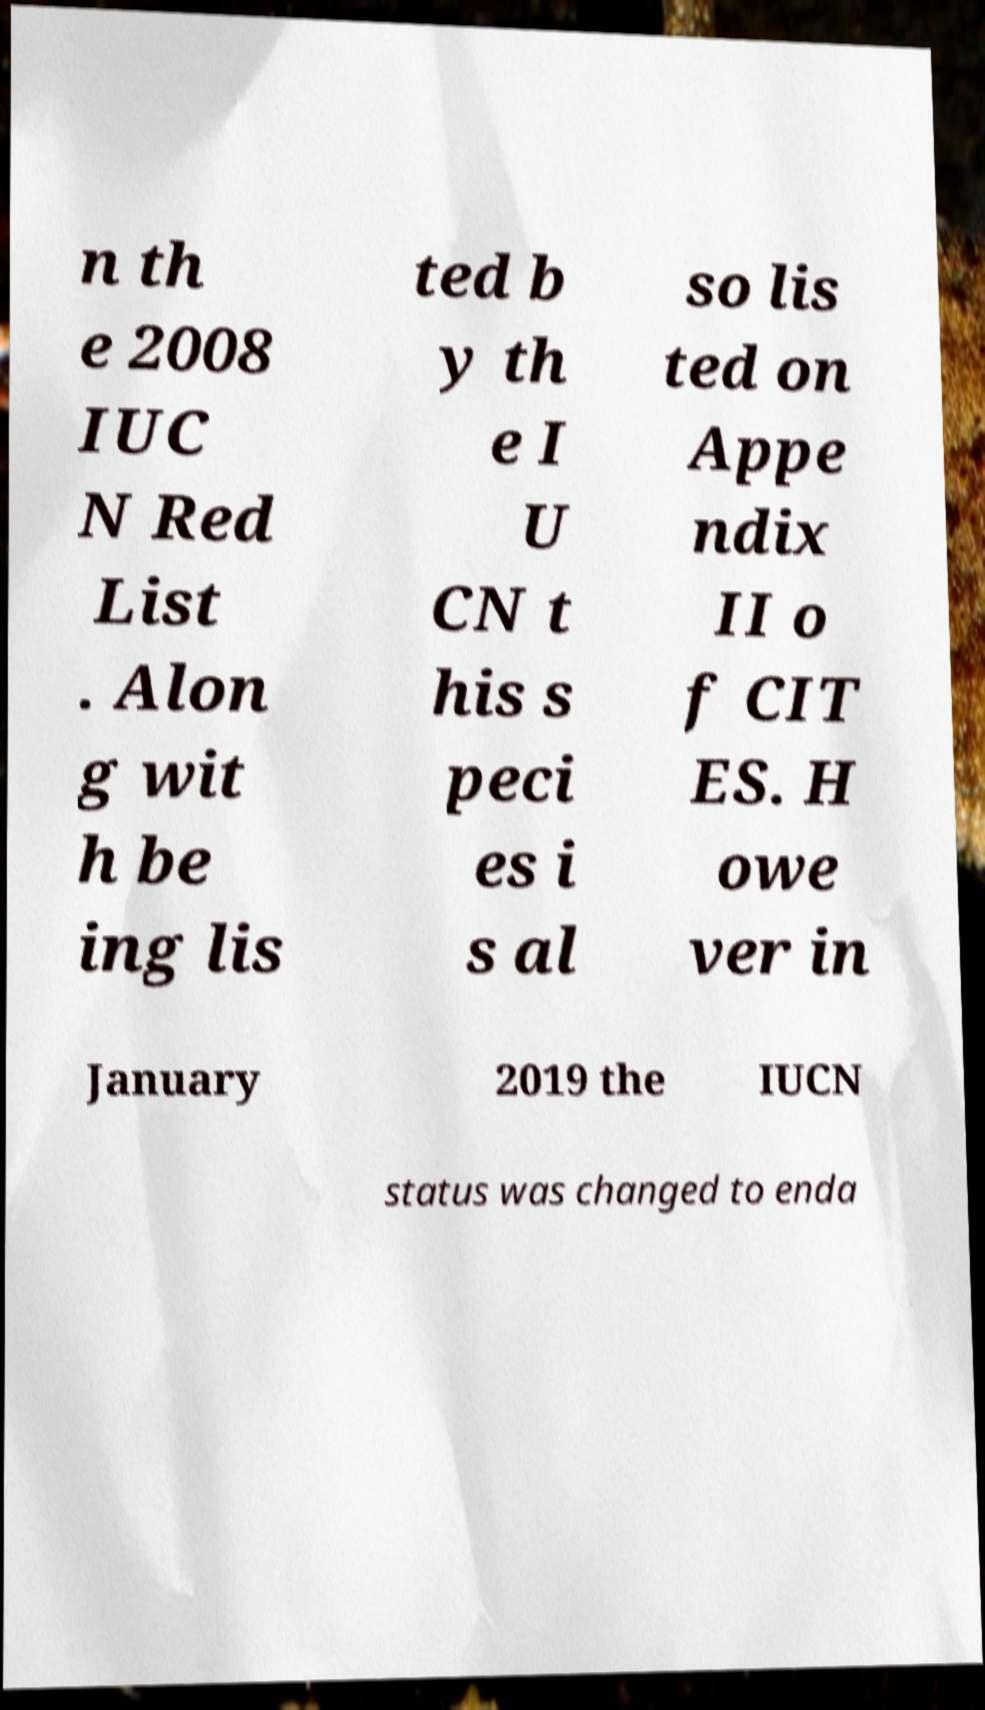I need the written content from this picture converted into text. Can you do that? n th e 2008 IUC N Red List . Alon g wit h be ing lis ted b y th e I U CN t his s peci es i s al so lis ted on Appe ndix II o f CIT ES. H owe ver in January 2019 the IUCN status was changed to enda 